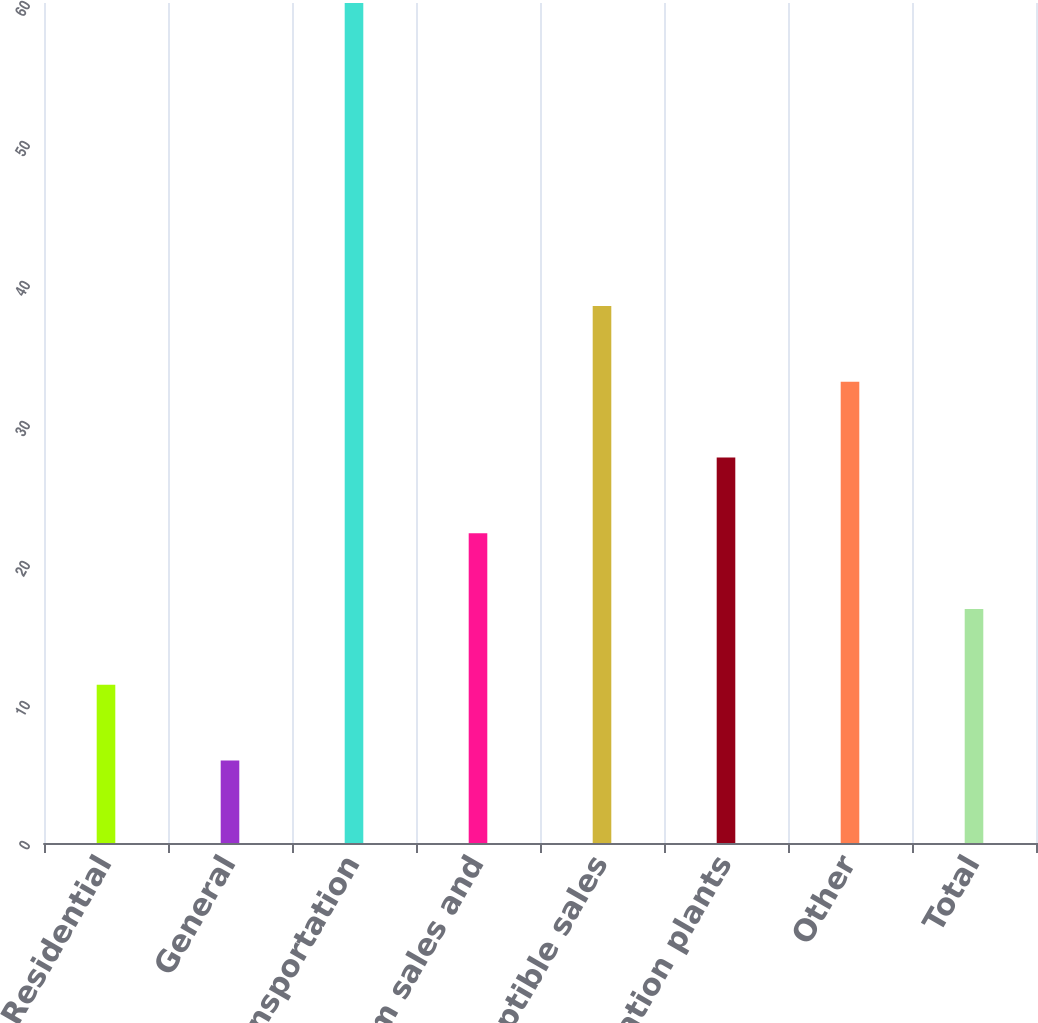<chart> <loc_0><loc_0><loc_500><loc_500><bar_chart><fcel>Residential<fcel>General<fcel>Firm transportation<fcel>Total firm sales and<fcel>Interruptible sales<fcel>Generation plants<fcel>Other<fcel>Total<nl><fcel>11.31<fcel>5.9<fcel>60<fcel>22.13<fcel>38.36<fcel>27.54<fcel>32.95<fcel>16.72<nl></chart> 